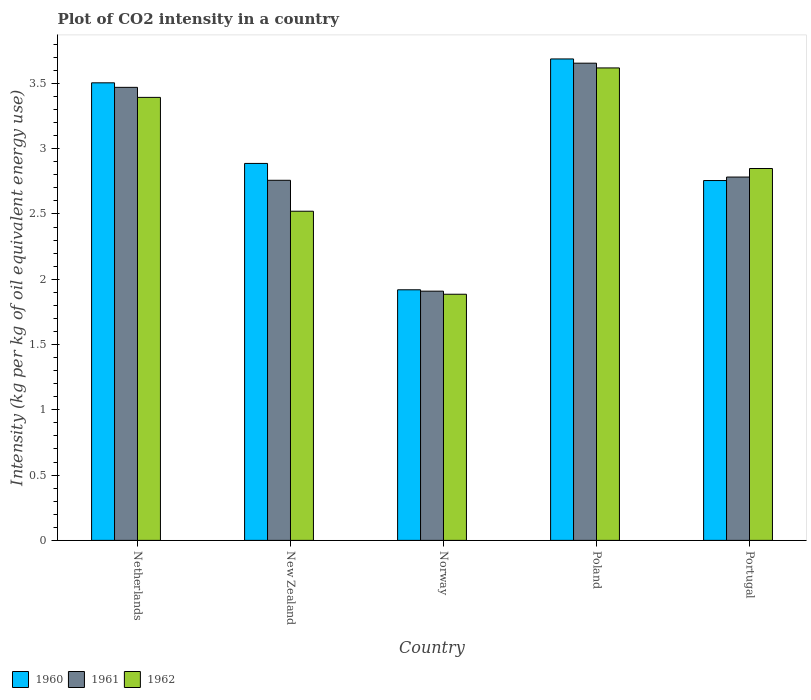How many different coloured bars are there?
Offer a terse response. 3. How many groups of bars are there?
Offer a very short reply. 5. How many bars are there on the 2nd tick from the right?
Give a very brief answer. 3. What is the label of the 5th group of bars from the left?
Your answer should be compact. Portugal. What is the CO2 intensity in in 1960 in Portugal?
Provide a succinct answer. 2.76. Across all countries, what is the maximum CO2 intensity in in 1961?
Provide a short and direct response. 3.66. Across all countries, what is the minimum CO2 intensity in in 1962?
Offer a very short reply. 1.89. In which country was the CO2 intensity in in 1962 minimum?
Ensure brevity in your answer.  Norway. What is the total CO2 intensity in in 1962 in the graph?
Your answer should be compact. 14.27. What is the difference between the CO2 intensity in in 1961 in Netherlands and that in Poland?
Ensure brevity in your answer.  -0.19. What is the difference between the CO2 intensity in in 1960 in Portugal and the CO2 intensity in in 1961 in Norway?
Make the answer very short. 0.85. What is the average CO2 intensity in in 1960 per country?
Keep it short and to the point. 2.95. What is the difference between the CO2 intensity in of/in 1960 and CO2 intensity in of/in 1962 in Norway?
Offer a terse response. 0.03. What is the ratio of the CO2 intensity in in 1961 in Netherlands to that in Poland?
Your response must be concise. 0.95. Is the CO2 intensity in in 1962 in Netherlands less than that in Portugal?
Provide a short and direct response. No. What is the difference between the highest and the second highest CO2 intensity in in 1961?
Keep it short and to the point. 0.69. What is the difference between the highest and the lowest CO2 intensity in in 1961?
Your response must be concise. 1.75. In how many countries, is the CO2 intensity in in 1960 greater than the average CO2 intensity in in 1960 taken over all countries?
Give a very brief answer. 2. Is the sum of the CO2 intensity in in 1961 in Poland and Portugal greater than the maximum CO2 intensity in in 1960 across all countries?
Your answer should be compact. Yes. Is it the case that in every country, the sum of the CO2 intensity in in 1962 and CO2 intensity in in 1961 is greater than the CO2 intensity in in 1960?
Ensure brevity in your answer.  Yes. Are all the bars in the graph horizontal?
Make the answer very short. No. What is the difference between two consecutive major ticks on the Y-axis?
Keep it short and to the point. 0.5. Does the graph contain any zero values?
Make the answer very short. No. Does the graph contain grids?
Ensure brevity in your answer.  No. Where does the legend appear in the graph?
Offer a very short reply. Bottom left. How are the legend labels stacked?
Your answer should be very brief. Horizontal. What is the title of the graph?
Provide a short and direct response. Plot of CO2 intensity in a country. Does "1991" appear as one of the legend labels in the graph?
Provide a succinct answer. No. What is the label or title of the X-axis?
Your response must be concise. Country. What is the label or title of the Y-axis?
Provide a short and direct response. Intensity (kg per kg of oil equivalent energy use). What is the Intensity (kg per kg of oil equivalent energy use) in 1960 in Netherlands?
Offer a very short reply. 3.5. What is the Intensity (kg per kg of oil equivalent energy use) of 1961 in Netherlands?
Your response must be concise. 3.47. What is the Intensity (kg per kg of oil equivalent energy use) of 1962 in Netherlands?
Your answer should be very brief. 3.39. What is the Intensity (kg per kg of oil equivalent energy use) in 1960 in New Zealand?
Your answer should be compact. 2.89. What is the Intensity (kg per kg of oil equivalent energy use) of 1961 in New Zealand?
Provide a succinct answer. 2.76. What is the Intensity (kg per kg of oil equivalent energy use) in 1962 in New Zealand?
Provide a succinct answer. 2.52. What is the Intensity (kg per kg of oil equivalent energy use) of 1960 in Norway?
Keep it short and to the point. 1.92. What is the Intensity (kg per kg of oil equivalent energy use) in 1961 in Norway?
Offer a very short reply. 1.91. What is the Intensity (kg per kg of oil equivalent energy use) in 1962 in Norway?
Ensure brevity in your answer.  1.89. What is the Intensity (kg per kg of oil equivalent energy use) in 1960 in Poland?
Your answer should be very brief. 3.69. What is the Intensity (kg per kg of oil equivalent energy use) of 1961 in Poland?
Keep it short and to the point. 3.66. What is the Intensity (kg per kg of oil equivalent energy use) in 1962 in Poland?
Make the answer very short. 3.62. What is the Intensity (kg per kg of oil equivalent energy use) in 1960 in Portugal?
Ensure brevity in your answer.  2.76. What is the Intensity (kg per kg of oil equivalent energy use) in 1961 in Portugal?
Offer a terse response. 2.78. What is the Intensity (kg per kg of oil equivalent energy use) of 1962 in Portugal?
Your answer should be very brief. 2.85. Across all countries, what is the maximum Intensity (kg per kg of oil equivalent energy use) in 1960?
Offer a very short reply. 3.69. Across all countries, what is the maximum Intensity (kg per kg of oil equivalent energy use) of 1961?
Offer a very short reply. 3.66. Across all countries, what is the maximum Intensity (kg per kg of oil equivalent energy use) in 1962?
Make the answer very short. 3.62. Across all countries, what is the minimum Intensity (kg per kg of oil equivalent energy use) of 1960?
Keep it short and to the point. 1.92. Across all countries, what is the minimum Intensity (kg per kg of oil equivalent energy use) of 1961?
Provide a succinct answer. 1.91. Across all countries, what is the minimum Intensity (kg per kg of oil equivalent energy use) in 1962?
Keep it short and to the point. 1.89. What is the total Intensity (kg per kg of oil equivalent energy use) in 1960 in the graph?
Give a very brief answer. 14.75. What is the total Intensity (kg per kg of oil equivalent energy use) in 1961 in the graph?
Give a very brief answer. 14.57. What is the total Intensity (kg per kg of oil equivalent energy use) in 1962 in the graph?
Keep it short and to the point. 14.27. What is the difference between the Intensity (kg per kg of oil equivalent energy use) of 1960 in Netherlands and that in New Zealand?
Offer a terse response. 0.62. What is the difference between the Intensity (kg per kg of oil equivalent energy use) of 1961 in Netherlands and that in New Zealand?
Your answer should be compact. 0.71. What is the difference between the Intensity (kg per kg of oil equivalent energy use) of 1962 in Netherlands and that in New Zealand?
Keep it short and to the point. 0.87. What is the difference between the Intensity (kg per kg of oil equivalent energy use) in 1960 in Netherlands and that in Norway?
Keep it short and to the point. 1.59. What is the difference between the Intensity (kg per kg of oil equivalent energy use) in 1961 in Netherlands and that in Norway?
Offer a very short reply. 1.56. What is the difference between the Intensity (kg per kg of oil equivalent energy use) in 1962 in Netherlands and that in Norway?
Make the answer very short. 1.51. What is the difference between the Intensity (kg per kg of oil equivalent energy use) of 1960 in Netherlands and that in Poland?
Provide a short and direct response. -0.18. What is the difference between the Intensity (kg per kg of oil equivalent energy use) in 1961 in Netherlands and that in Poland?
Keep it short and to the point. -0.19. What is the difference between the Intensity (kg per kg of oil equivalent energy use) in 1962 in Netherlands and that in Poland?
Keep it short and to the point. -0.23. What is the difference between the Intensity (kg per kg of oil equivalent energy use) in 1960 in Netherlands and that in Portugal?
Offer a terse response. 0.75. What is the difference between the Intensity (kg per kg of oil equivalent energy use) in 1961 in Netherlands and that in Portugal?
Provide a succinct answer. 0.69. What is the difference between the Intensity (kg per kg of oil equivalent energy use) of 1962 in Netherlands and that in Portugal?
Offer a terse response. 0.54. What is the difference between the Intensity (kg per kg of oil equivalent energy use) in 1960 in New Zealand and that in Norway?
Keep it short and to the point. 0.97. What is the difference between the Intensity (kg per kg of oil equivalent energy use) of 1961 in New Zealand and that in Norway?
Provide a short and direct response. 0.85. What is the difference between the Intensity (kg per kg of oil equivalent energy use) in 1962 in New Zealand and that in Norway?
Provide a succinct answer. 0.64. What is the difference between the Intensity (kg per kg of oil equivalent energy use) of 1960 in New Zealand and that in Poland?
Give a very brief answer. -0.8. What is the difference between the Intensity (kg per kg of oil equivalent energy use) of 1961 in New Zealand and that in Poland?
Make the answer very short. -0.9. What is the difference between the Intensity (kg per kg of oil equivalent energy use) of 1962 in New Zealand and that in Poland?
Your response must be concise. -1.1. What is the difference between the Intensity (kg per kg of oil equivalent energy use) of 1960 in New Zealand and that in Portugal?
Ensure brevity in your answer.  0.13. What is the difference between the Intensity (kg per kg of oil equivalent energy use) in 1961 in New Zealand and that in Portugal?
Make the answer very short. -0.02. What is the difference between the Intensity (kg per kg of oil equivalent energy use) in 1962 in New Zealand and that in Portugal?
Your response must be concise. -0.33. What is the difference between the Intensity (kg per kg of oil equivalent energy use) in 1960 in Norway and that in Poland?
Provide a short and direct response. -1.77. What is the difference between the Intensity (kg per kg of oil equivalent energy use) in 1961 in Norway and that in Poland?
Make the answer very short. -1.75. What is the difference between the Intensity (kg per kg of oil equivalent energy use) in 1962 in Norway and that in Poland?
Make the answer very short. -1.73. What is the difference between the Intensity (kg per kg of oil equivalent energy use) in 1960 in Norway and that in Portugal?
Your answer should be compact. -0.84. What is the difference between the Intensity (kg per kg of oil equivalent energy use) in 1961 in Norway and that in Portugal?
Give a very brief answer. -0.87. What is the difference between the Intensity (kg per kg of oil equivalent energy use) of 1962 in Norway and that in Portugal?
Offer a very short reply. -0.96. What is the difference between the Intensity (kg per kg of oil equivalent energy use) in 1960 in Poland and that in Portugal?
Ensure brevity in your answer.  0.93. What is the difference between the Intensity (kg per kg of oil equivalent energy use) in 1961 in Poland and that in Portugal?
Provide a succinct answer. 0.87. What is the difference between the Intensity (kg per kg of oil equivalent energy use) in 1962 in Poland and that in Portugal?
Your answer should be compact. 0.77. What is the difference between the Intensity (kg per kg of oil equivalent energy use) of 1960 in Netherlands and the Intensity (kg per kg of oil equivalent energy use) of 1961 in New Zealand?
Give a very brief answer. 0.75. What is the difference between the Intensity (kg per kg of oil equivalent energy use) of 1960 in Netherlands and the Intensity (kg per kg of oil equivalent energy use) of 1962 in New Zealand?
Keep it short and to the point. 0.98. What is the difference between the Intensity (kg per kg of oil equivalent energy use) of 1961 in Netherlands and the Intensity (kg per kg of oil equivalent energy use) of 1962 in New Zealand?
Ensure brevity in your answer.  0.95. What is the difference between the Intensity (kg per kg of oil equivalent energy use) of 1960 in Netherlands and the Intensity (kg per kg of oil equivalent energy use) of 1961 in Norway?
Offer a terse response. 1.6. What is the difference between the Intensity (kg per kg of oil equivalent energy use) in 1960 in Netherlands and the Intensity (kg per kg of oil equivalent energy use) in 1962 in Norway?
Make the answer very short. 1.62. What is the difference between the Intensity (kg per kg of oil equivalent energy use) of 1961 in Netherlands and the Intensity (kg per kg of oil equivalent energy use) of 1962 in Norway?
Your answer should be very brief. 1.58. What is the difference between the Intensity (kg per kg of oil equivalent energy use) in 1960 in Netherlands and the Intensity (kg per kg of oil equivalent energy use) in 1961 in Poland?
Ensure brevity in your answer.  -0.15. What is the difference between the Intensity (kg per kg of oil equivalent energy use) in 1960 in Netherlands and the Intensity (kg per kg of oil equivalent energy use) in 1962 in Poland?
Give a very brief answer. -0.11. What is the difference between the Intensity (kg per kg of oil equivalent energy use) of 1961 in Netherlands and the Intensity (kg per kg of oil equivalent energy use) of 1962 in Poland?
Your response must be concise. -0.15. What is the difference between the Intensity (kg per kg of oil equivalent energy use) of 1960 in Netherlands and the Intensity (kg per kg of oil equivalent energy use) of 1961 in Portugal?
Ensure brevity in your answer.  0.72. What is the difference between the Intensity (kg per kg of oil equivalent energy use) in 1960 in Netherlands and the Intensity (kg per kg of oil equivalent energy use) in 1962 in Portugal?
Your response must be concise. 0.66. What is the difference between the Intensity (kg per kg of oil equivalent energy use) of 1961 in Netherlands and the Intensity (kg per kg of oil equivalent energy use) of 1962 in Portugal?
Ensure brevity in your answer.  0.62. What is the difference between the Intensity (kg per kg of oil equivalent energy use) of 1960 in New Zealand and the Intensity (kg per kg of oil equivalent energy use) of 1961 in Norway?
Offer a very short reply. 0.98. What is the difference between the Intensity (kg per kg of oil equivalent energy use) of 1960 in New Zealand and the Intensity (kg per kg of oil equivalent energy use) of 1962 in Norway?
Your response must be concise. 1. What is the difference between the Intensity (kg per kg of oil equivalent energy use) in 1961 in New Zealand and the Intensity (kg per kg of oil equivalent energy use) in 1962 in Norway?
Make the answer very short. 0.87. What is the difference between the Intensity (kg per kg of oil equivalent energy use) in 1960 in New Zealand and the Intensity (kg per kg of oil equivalent energy use) in 1961 in Poland?
Provide a succinct answer. -0.77. What is the difference between the Intensity (kg per kg of oil equivalent energy use) of 1960 in New Zealand and the Intensity (kg per kg of oil equivalent energy use) of 1962 in Poland?
Offer a very short reply. -0.73. What is the difference between the Intensity (kg per kg of oil equivalent energy use) in 1961 in New Zealand and the Intensity (kg per kg of oil equivalent energy use) in 1962 in Poland?
Make the answer very short. -0.86. What is the difference between the Intensity (kg per kg of oil equivalent energy use) of 1960 in New Zealand and the Intensity (kg per kg of oil equivalent energy use) of 1961 in Portugal?
Ensure brevity in your answer.  0.1. What is the difference between the Intensity (kg per kg of oil equivalent energy use) in 1960 in New Zealand and the Intensity (kg per kg of oil equivalent energy use) in 1962 in Portugal?
Give a very brief answer. 0.04. What is the difference between the Intensity (kg per kg of oil equivalent energy use) in 1961 in New Zealand and the Intensity (kg per kg of oil equivalent energy use) in 1962 in Portugal?
Give a very brief answer. -0.09. What is the difference between the Intensity (kg per kg of oil equivalent energy use) in 1960 in Norway and the Intensity (kg per kg of oil equivalent energy use) in 1961 in Poland?
Your response must be concise. -1.74. What is the difference between the Intensity (kg per kg of oil equivalent energy use) in 1960 in Norway and the Intensity (kg per kg of oil equivalent energy use) in 1962 in Poland?
Ensure brevity in your answer.  -1.7. What is the difference between the Intensity (kg per kg of oil equivalent energy use) in 1961 in Norway and the Intensity (kg per kg of oil equivalent energy use) in 1962 in Poland?
Your response must be concise. -1.71. What is the difference between the Intensity (kg per kg of oil equivalent energy use) of 1960 in Norway and the Intensity (kg per kg of oil equivalent energy use) of 1961 in Portugal?
Your response must be concise. -0.86. What is the difference between the Intensity (kg per kg of oil equivalent energy use) in 1960 in Norway and the Intensity (kg per kg of oil equivalent energy use) in 1962 in Portugal?
Provide a succinct answer. -0.93. What is the difference between the Intensity (kg per kg of oil equivalent energy use) in 1961 in Norway and the Intensity (kg per kg of oil equivalent energy use) in 1962 in Portugal?
Your answer should be compact. -0.94. What is the difference between the Intensity (kg per kg of oil equivalent energy use) in 1960 in Poland and the Intensity (kg per kg of oil equivalent energy use) in 1961 in Portugal?
Your answer should be compact. 0.9. What is the difference between the Intensity (kg per kg of oil equivalent energy use) of 1960 in Poland and the Intensity (kg per kg of oil equivalent energy use) of 1962 in Portugal?
Give a very brief answer. 0.84. What is the difference between the Intensity (kg per kg of oil equivalent energy use) of 1961 in Poland and the Intensity (kg per kg of oil equivalent energy use) of 1962 in Portugal?
Keep it short and to the point. 0.81. What is the average Intensity (kg per kg of oil equivalent energy use) in 1960 per country?
Your answer should be very brief. 2.95. What is the average Intensity (kg per kg of oil equivalent energy use) of 1961 per country?
Ensure brevity in your answer.  2.91. What is the average Intensity (kg per kg of oil equivalent energy use) in 1962 per country?
Ensure brevity in your answer.  2.85. What is the difference between the Intensity (kg per kg of oil equivalent energy use) of 1960 and Intensity (kg per kg of oil equivalent energy use) of 1961 in Netherlands?
Your answer should be very brief. 0.03. What is the difference between the Intensity (kg per kg of oil equivalent energy use) in 1960 and Intensity (kg per kg of oil equivalent energy use) in 1962 in Netherlands?
Your answer should be very brief. 0.11. What is the difference between the Intensity (kg per kg of oil equivalent energy use) in 1961 and Intensity (kg per kg of oil equivalent energy use) in 1962 in Netherlands?
Ensure brevity in your answer.  0.08. What is the difference between the Intensity (kg per kg of oil equivalent energy use) in 1960 and Intensity (kg per kg of oil equivalent energy use) in 1961 in New Zealand?
Provide a succinct answer. 0.13. What is the difference between the Intensity (kg per kg of oil equivalent energy use) in 1960 and Intensity (kg per kg of oil equivalent energy use) in 1962 in New Zealand?
Keep it short and to the point. 0.37. What is the difference between the Intensity (kg per kg of oil equivalent energy use) of 1961 and Intensity (kg per kg of oil equivalent energy use) of 1962 in New Zealand?
Your answer should be compact. 0.24. What is the difference between the Intensity (kg per kg of oil equivalent energy use) in 1960 and Intensity (kg per kg of oil equivalent energy use) in 1961 in Norway?
Make the answer very short. 0.01. What is the difference between the Intensity (kg per kg of oil equivalent energy use) in 1960 and Intensity (kg per kg of oil equivalent energy use) in 1962 in Norway?
Provide a succinct answer. 0.03. What is the difference between the Intensity (kg per kg of oil equivalent energy use) in 1961 and Intensity (kg per kg of oil equivalent energy use) in 1962 in Norway?
Ensure brevity in your answer.  0.02. What is the difference between the Intensity (kg per kg of oil equivalent energy use) of 1960 and Intensity (kg per kg of oil equivalent energy use) of 1961 in Poland?
Offer a very short reply. 0.03. What is the difference between the Intensity (kg per kg of oil equivalent energy use) in 1960 and Intensity (kg per kg of oil equivalent energy use) in 1962 in Poland?
Provide a short and direct response. 0.07. What is the difference between the Intensity (kg per kg of oil equivalent energy use) of 1961 and Intensity (kg per kg of oil equivalent energy use) of 1962 in Poland?
Make the answer very short. 0.04. What is the difference between the Intensity (kg per kg of oil equivalent energy use) in 1960 and Intensity (kg per kg of oil equivalent energy use) in 1961 in Portugal?
Ensure brevity in your answer.  -0.03. What is the difference between the Intensity (kg per kg of oil equivalent energy use) of 1960 and Intensity (kg per kg of oil equivalent energy use) of 1962 in Portugal?
Your answer should be compact. -0.09. What is the difference between the Intensity (kg per kg of oil equivalent energy use) in 1961 and Intensity (kg per kg of oil equivalent energy use) in 1962 in Portugal?
Provide a succinct answer. -0.07. What is the ratio of the Intensity (kg per kg of oil equivalent energy use) of 1960 in Netherlands to that in New Zealand?
Your answer should be very brief. 1.21. What is the ratio of the Intensity (kg per kg of oil equivalent energy use) in 1961 in Netherlands to that in New Zealand?
Provide a succinct answer. 1.26. What is the ratio of the Intensity (kg per kg of oil equivalent energy use) of 1962 in Netherlands to that in New Zealand?
Provide a short and direct response. 1.35. What is the ratio of the Intensity (kg per kg of oil equivalent energy use) of 1960 in Netherlands to that in Norway?
Offer a terse response. 1.83. What is the ratio of the Intensity (kg per kg of oil equivalent energy use) of 1961 in Netherlands to that in Norway?
Your answer should be very brief. 1.82. What is the ratio of the Intensity (kg per kg of oil equivalent energy use) of 1962 in Netherlands to that in Norway?
Your answer should be compact. 1.8. What is the ratio of the Intensity (kg per kg of oil equivalent energy use) in 1960 in Netherlands to that in Poland?
Your answer should be very brief. 0.95. What is the ratio of the Intensity (kg per kg of oil equivalent energy use) in 1961 in Netherlands to that in Poland?
Provide a succinct answer. 0.95. What is the ratio of the Intensity (kg per kg of oil equivalent energy use) in 1962 in Netherlands to that in Poland?
Provide a succinct answer. 0.94. What is the ratio of the Intensity (kg per kg of oil equivalent energy use) of 1960 in Netherlands to that in Portugal?
Make the answer very short. 1.27. What is the ratio of the Intensity (kg per kg of oil equivalent energy use) in 1961 in Netherlands to that in Portugal?
Provide a short and direct response. 1.25. What is the ratio of the Intensity (kg per kg of oil equivalent energy use) of 1962 in Netherlands to that in Portugal?
Your answer should be compact. 1.19. What is the ratio of the Intensity (kg per kg of oil equivalent energy use) in 1960 in New Zealand to that in Norway?
Give a very brief answer. 1.5. What is the ratio of the Intensity (kg per kg of oil equivalent energy use) in 1961 in New Zealand to that in Norway?
Your answer should be very brief. 1.44. What is the ratio of the Intensity (kg per kg of oil equivalent energy use) in 1962 in New Zealand to that in Norway?
Provide a succinct answer. 1.34. What is the ratio of the Intensity (kg per kg of oil equivalent energy use) of 1960 in New Zealand to that in Poland?
Keep it short and to the point. 0.78. What is the ratio of the Intensity (kg per kg of oil equivalent energy use) in 1961 in New Zealand to that in Poland?
Keep it short and to the point. 0.75. What is the ratio of the Intensity (kg per kg of oil equivalent energy use) in 1962 in New Zealand to that in Poland?
Give a very brief answer. 0.7. What is the ratio of the Intensity (kg per kg of oil equivalent energy use) in 1960 in New Zealand to that in Portugal?
Offer a very short reply. 1.05. What is the ratio of the Intensity (kg per kg of oil equivalent energy use) of 1961 in New Zealand to that in Portugal?
Your answer should be very brief. 0.99. What is the ratio of the Intensity (kg per kg of oil equivalent energy use) in 1962 in New Zealand to that in Portugal?
Keep it short and to the point. 0.89. What is the ratio of the Intensity (kg per kg of oil equivalent energy use) in 1960 in Norway to that in Poland?
Offer a very short reply. 0.52. What is the ratio of the Intensity (kg per kg of oil equivalent energy use) in 1961 in Norway to that in Poland?
Your answer should be compact. 0.52. What is the ratio of the Intensity (kg per kg of oil equivalent energy use) in 1962 in Norway to that in Poland?
Your answer should be very brief. 0.52. What is the ratio of the Intensity (kg per kg of oil equivalent energy use) of 1960 in Norway to that in Portugal?
Offer a very short reply. 0.7. What is the ratio of the Intensity (kg per kg of oil equivalent energy use) in 1961 in Norway to that in Portugal?
Your answer should be compact. 0.69. What is the ratio of the Intensity (kg per kg of oil equivalent energy use) in 1962 in Norway to that in Portugal?
Give a very brief answer. 0.66. What is the ratio of the Intensity (kg per kg of oil equivalent energy use) in 1960 in Poland to that in Portugal?
Keep it short and to the point. 1.34. What is the ratio of the Intensity (kg per kg of oil equivalent energy use) of 1961 in Poland to that in Portugal?
Your response must be concise. 1.31. What is the ratio of the Intensity (kg per kg of oil equivalent energy use) of 1962 in Poland to that in Portugal?
Ensure brevity in your answer.  1.27. What is the difference between the highest and the second highest Intensity (kg per kg of oil equivalent energy use) in 1960?
Your response must be concise. 0.18. What is the difference between the highest and the second highest Intensity (kg per kg of oil equivalent energy use) of 1961?
Provide a short and direct response. 0.19. What is the difference between the highest and the second highest Intensity (kg per kg of oil equivalent energy use) of 1962?
Make the answer very short. 0.23. What is the difference between the highest and the lowest Intensity (kg per kg of oil equivalent energy use) in 1960?
Your answer should be compact. 1.77. What is the difference between the highest and the lowest Intensity (kg per kg of oil equivalent energy use) of 1961?
Offer a very short reply. 1.75. What is the difference between the highest and the lowest Intensity (kg per kg of oil equivalent energy use) of 1962?
Make the answer very short. 1.73. 